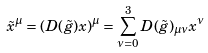<formula> <loc_0><loc_0><loc_500><loc_500>\tilde { x } ^ { \mu } = \left ( D ( \tilde { g } ) x \right ) ^ { \mu } = \sum _ { \nu = 0 } ^ { 3 } D ( \tilde { g } ) _ { \mu \nu } x ^ { \nu }</formula> 